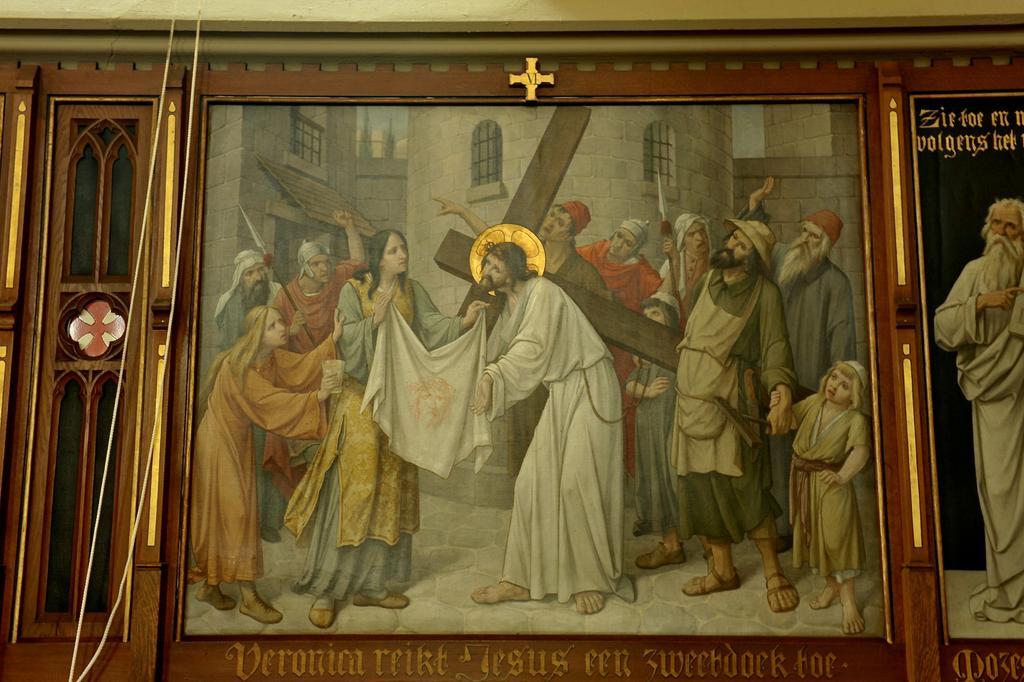In one or two sentences, can you explain what this image depicts? In this picture we can see photo frames, there are pictures of persons in these frames, at the bottom there is some text. 